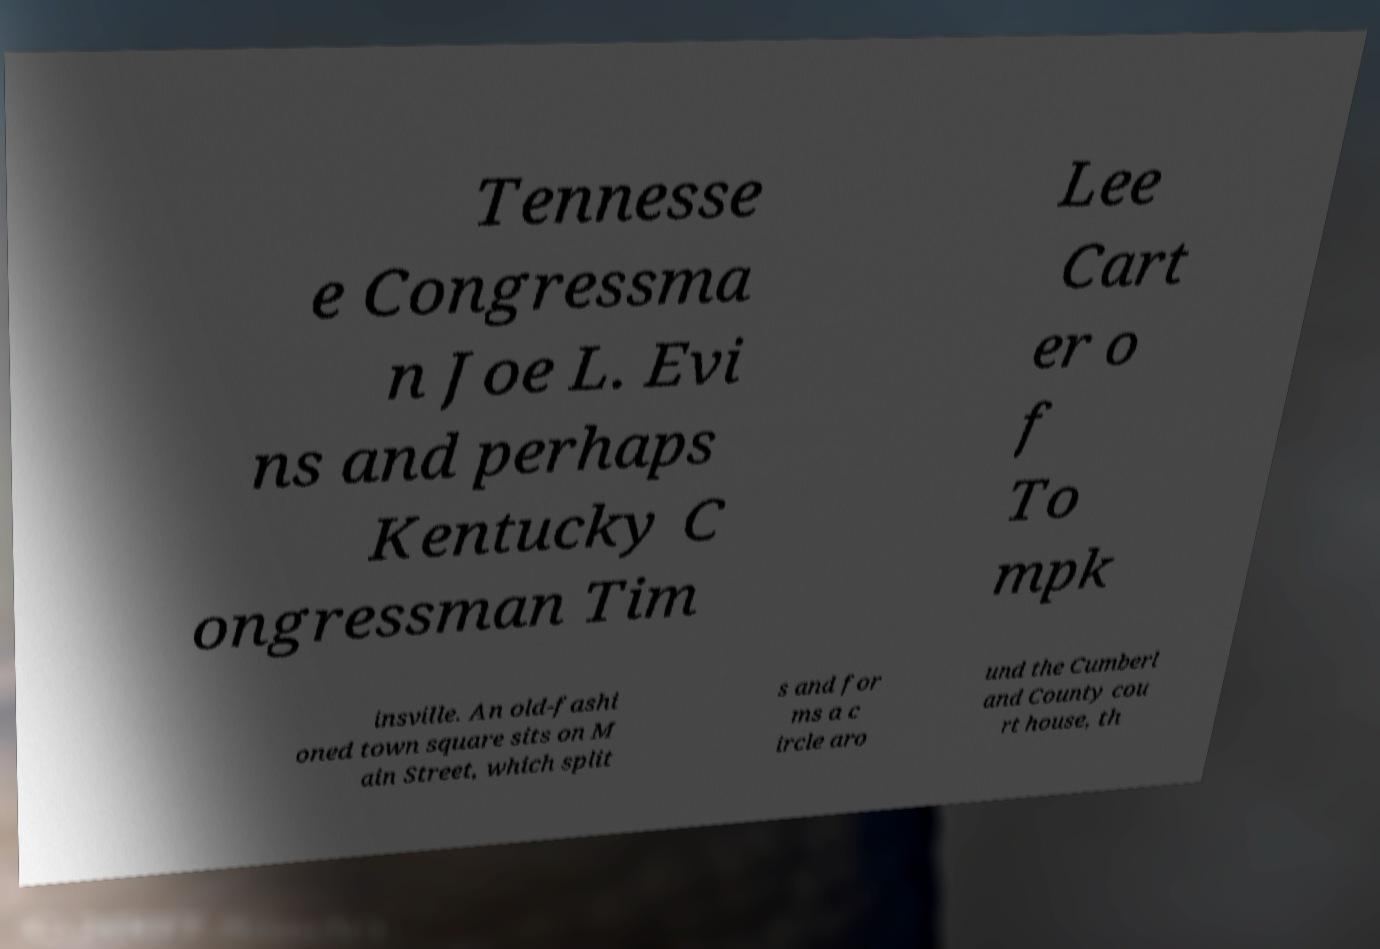What messages or text are displayed in this image? I need them in a readable, typed format. Tennesse e Congressma n Joe L. Evi ns and perhaps Kentucky C ongressman Tim Lee Cart er o f To mpk insville. An old-fashi oned town square sits on M ain Street, which split s and for ms a c ircle aro und the Cumberl and County cou rt house, th 